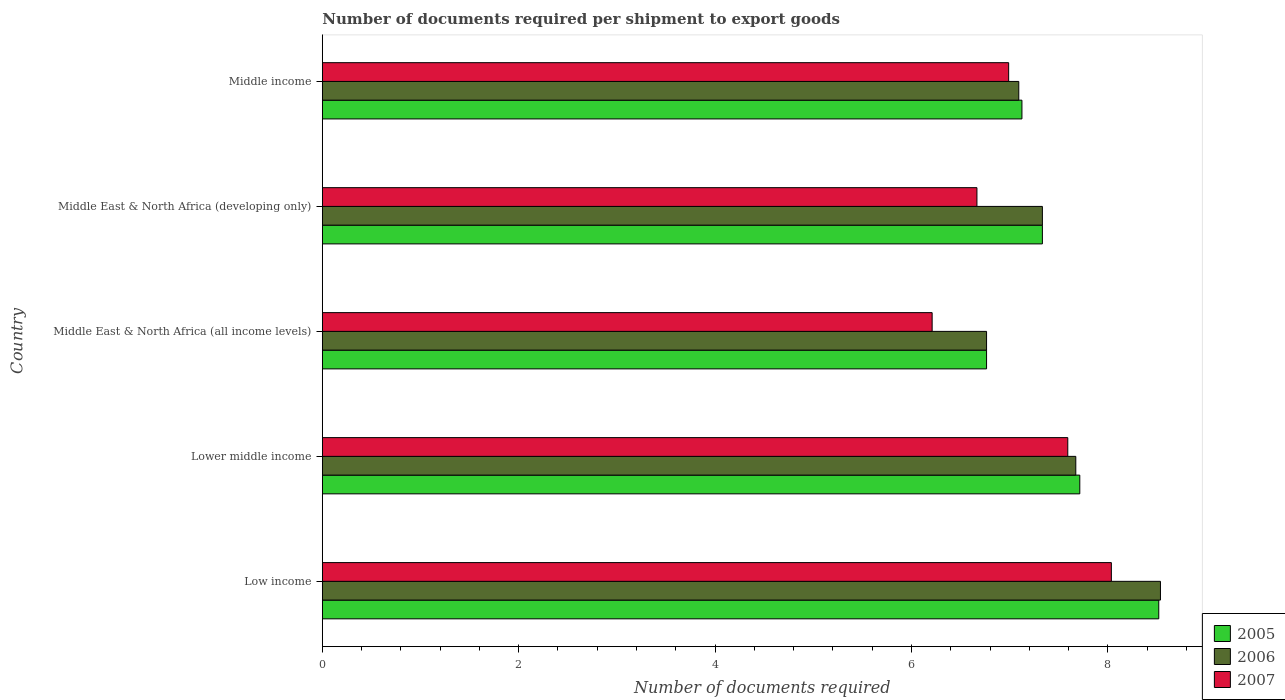Are the number of bars per tick equal to the number of legend labels?
Your answer should be very brief. Yes. Are the number of bars on each tick of the Y-axis equal?
Offer a very short reply. Yes. How many bars are there on the 3rd tick from the bottom?
Provide a succinct answer. 3. What is the label of the 2nd group of bars from the top?
Your answer should be compact. Middle East & North Africa (developing only). What is the number of documents required per shipment to export goods in 2006 in Middle East & North Africa (all income levels)?
Offer a very short reply. 6.76. Across all countries, what is the maximum number of documents required per shipment to export goods in 2006?
Keep it short and to the point. 8.54. Across all countries, what is the minimum number of documents required per shipment to export goods in 2005?
Your answer should be very brief. 6.76. In which country was the number of documents required per shipment to export goods in 2005 minimum?
Provide a short and direct response. Middle East & North Africa (all income levels). What is the total number of documents required per shipment to export goods in 2005 in the graph?
Offer a terse response. 37.46. What is the difference between the number of documents required per shipment to export goods in 2006 in Middle East & North Africa (all income levels) and that in Middle East & North Africa (developing only)?
Make the answer very short. -0.57. What is the difference between the number of documents required per shipment to export goods in 2006 in Middle East & North Africa (developing only) and the number of documents required per shipment to export goods in 2005 in Middle East & North Africa (all income levels)?
Offer a terse response. 0.57. What is the average number of documents required per shipment to export goods in 2005 per country?
Offer a terse response. 7.49. What is the difference between the number of documents required per shipment to export goods in 2006 and number of documents required per shipment to export goods in 2007 in Middle income?
Your response must be concise. 0.1. In how many countries, is the number of documents required per shipment to export goods in 2007 greater than 4 ?
Keep it short and to the point. 5. What is the ratio of the number of documents required per shipment to export goods in 2005 in Middle East & North Africa (all income levels) to that in Middle income?
Ensure brevity in your answer.  0.95. Is the number of documents required per shipment to export goods in 2007 in Middle East & North Africa (all income levels) less than that in Middle income?
Your answer should be compact. Yes. Is the difference between the number of documents required per shipment to export goods in 2006 in Lower middle income and Middle East & North Africa (developing only) greater than the difference between the number of documents required per shipment to export goods in 2007 in Lower middle income and Middle East & North Africa (developing only)?
Provide a short and direct response. No. What is the difference between the highest and the second highest number of documents required per shipment to export goods in 2005?
Provide a succinct answer. 0.8. What is the difference between the highest and the lowest number of documents required per shipment to export goods in 2006?
Provide a succinct answer. 1.77. What does the 2nd bar from the top in Middle East & North Africa (all income levels) represents?
Your answer should be compact. 2006. What does the 3rd bar from the bottom in Low income represents?
Offer a very short reply. 2007. Is it the case that in every country, the sum of the number of documents required per shipment to export goods in 2005 and number of documents required per shipment to export goods in 2007 is greater than the number of documents required per shipment to export goods in 2006?
Provide a succinct answer. Yes. Are all the bars in the graph horizontal?
Your response must be concise. Yes. Where does the legend appear in the graph?
Keep it short and to the point. Bottom right. How many legend labels are there?
Your response must be concise. 3. How are the legend labels stacked?
Ensure brevity in your answer.  Vertical. What is the title of the graph?
Make the answer very short. Number of documents required per shipment to export goods. Does "1994" appear as one of the legend labels in the graph?
Give a very brief answer. No. What is the label or title of the X-axis?
Keep it short and to the point. Number of documents required. What is the label or title of the Y-axis?
Provide a succinct answer. Country. What is the Number of documents required in 2005 in Low income?
Give a very brief answer. 8.52. What is the Number of documents required in 2006 in Low income?
Provide a succinct answer. 8.54. What is the Number of documents required of 2007 in Low income?
Ensure brevity in your answer.  8.04. What is the Number of documents required of 2005 in Lower middle income?
Provide a succinct answer. 7.71. What is the Number of documents required in 2006 in Lower middle income?
Provide a short and direct response. 7.67. What is the Number of documents required of 2007 in Lower middle income?
Provide a succinct answer. 7.59. What is the Number of documents required in 2005 in Middle East & North Africa (all income levels)?
Ensure brevity in your answer.  6.76. What is the Number of documents required of 2006 in Middle East & North Africa (all income levels)?
Offer a very short reply. 6.76. What is the Number of documents required in 2007 in Middle East & North Africa (all income levels)?
Make the answer very short. 6.21. What is the Number of documents required in 2005 in Middle East & North Africa (developing only)?
Make the answer very short. 7.33. What is the Number of documents required in 2006 in Middle East & North Africa (developing only)?
Your answer should be compact. 7.33. What is the Number of documents required in 2007 in Middle East & North Africa (developing only)?
Keep it short and to the point. 6.67. What is the Number of documents required in 2005 in Middle income?
Provide a short and direct response. 7.12. What is the Number of documents required of 2006 in Middle income?
Your answer should be very brief. 7.09. What is the Number of documents required of 2007 in Middle income?
Make the answer very short. 6.99. Across all countries, what is the maximum Number of documents required in 2005?
Provide a succinct answer. 8.52. Across all countries, what is the maximum Number of documents required in 2006?
Provide a short and direct response. 8.54. Across all countries, what is the maximum Number of documents required of 2007?
Ensure brevity in your answer.  8.04. Across all countries, what is the minimum Number of documents required in 2005?
Your answer should be very brief. 6.76. Across all countries, what is the minimum Number of documents required of 2006?
Make the answer very short. 6.76. Across all countries, what is the minimum Number of documents required in 2007?
Give a very brief answer. 6.21. What is the total Number of documents required in 2005 in the graph?
Your answer should be compact. 37.46. What is the total Number of documents required of 2006 in the graph?
Offer a terse response. 37.4. What is the total Number of documents required of 2007 in the graph?
Provide a succinct answer. 35.49. What is the difference between the Number of documents required in 2005 in Low income and that in Lower middle income?
Offer a very short reply. 0.8. What is the difference between the Number of documents required of 2006 in Low income and that in Lower middle income?
Provide a short and direct response. 0.86. What is the difference between the Number of documents required of 2007 in Low income and that in Lower middle income?
Make the answer very short. 0.44. What is the difference between the Number of documents required in 2005 in Low income and that in Middle East & North Africa (all income levels)?
Keep it short and to the point. 1.75. What is the difference between the Number of documents required of 2006 in Low income and that in Middle East & North Africa (all income levels)?
Keep it short and to the point. 1.77. What is the difference between the Number of documents required in 2007 in Low income and that in Middle East & North Africa (all income levels)?
Offer a very short reply. 1.83. What is the difference between the Number of documents required of 2005 in Low income and that in Middle East & North Africa (developing only)?
Give a very brief answer. 1.19. What is the difference between the Number of documents required in 2006 in Low income and that in Middle East & North Africa (developing only)?
Provide a succinct answer. 1.2. What is the difference between the Number of documents required in 2007 in Low income and that in Middle East & North Africa (developing only)?
Your answer should be compact. 1.37. What is the difference between the Number of documents required of 2005 in Low income and that in Middle income?
Ensure brevity in your answer.  1.39. What is the difference between the Number of documents required of 2006 in Low income and that in Middle income?
Make the answer very short. 1.44. What is the difference between the Number of documents required of 2007 in Low income and that in Middle income?
Keep it short and to the point. 1.05. What is the difference between the Number of documents required in 2005 in Lower middle income and that in Middle East & North Africa (all income levels)?
Keep it short and to the point. 0.95. What is the difference between the Number of documents required in 2006 in Lower middle income and that in Middle East & North Africa (all income levels)?
Offer a very short reply. 0.91. What is the difference between the Number of documents required of 2007 in Lower middle income and that in Middle East & North Africa (all income levels)?
Offer a very short reply. 1.38. What is the difference between the Number of documents required of 2005 in Lower middle income and that in Middle East & North Africa (developing only)?
Your answer should be compact. 0.38. What is the difference between the Number of documents required of 2006 in Lower middle income and that in Middle East & North Africa (developing only)?
Give a very brief answer. 0.34. What is the difference between the Number of documents required of 2007 in Lower middle income and that in Middle East & North Africa (developing only)?
Keep it short and to the point. 0.93. What is the difference between the Number of documents required in 2005 in Lower middle income and that in Middle income?
Provide a short and direct response. 0.59. What is the difference between the Number of documents required in 2006 in Lower middle income and that in Middle income?
Offer a very short reply. 0.58. What is the difference between the Number of documents required of 2007 in Lower middle income and that in Middle income?
Provide a short and direct response. 0.6. What is the difference between the Number of documents required of 2005 in Middle East & North Africa (all income levels) and that in Middle East & North Africa (developing only)?
Offer a terse response. -0.57. What is the difference between the Number of documents required in 2006 in Middle East & North Africa (all income levels) and that in Middle East & North Africa (developing only)?
Give a very brief answer. -0.57. What is the difference between the Number of documents required of 2007 in Middle East & North Africa (all income levels) and that in Middle East & North Africa (developing only)?
Offer a terse response. -0.46. What is the difference between the Number of documents required of 2005 in Middle East & North Africa (all income levels) and that in Middle income?
Provide a succinct answer. -0.36. What is the difference between the Number of documents required in 2006 in Middle East & North Africa (all income levels) and that in Middle income?
Provide a succinct answer. -0.33. What is the difference between the Number of documents required in 2007 in Middle East & North Africa (all income levels) and that in Middle income?
Ensure brevity in your answer.  -0.78. What is the difference between the Number of documents required of 2005 in Middle East & North Africa (developing only) and that in Middle income?
Your answer should be compact. 0.21. What is the difference between the Number of documents required in 2006 in Middle East & North Africa (developing only) and that in Middle income?
Offer a terse response. 0.24. What is the difference between the Number of documents required in 2007 in Middle East & North Africa (developing only) and that in Middle income?
Offer a terse response. -0.32. What is the difference between the Number of documents required in 2005 in Low income and the Number of documents required in 2006 in Lower middle income?
Ensure brevity in your answer.  0.84. What is the difference between the Number of documents required in 2005 in Low income and the Number of documents required in 2007 in Lower middle income?
Your response must be concise. 0.93. What is the difference between the Number of documents required of 2006 in Low income and the Number of documents required of 2007 in Lower middle income?
Give a very brief answer. 0.94. What is the difference between the Number of documents required in 2005 in Low income and the Number of documents required in 2006 in Middle East & North Africa (all income levels)?
Offer a very short reply. 1.75. What is the difference between the Number of documents required of 2005 in Low income and the Number of documents required of 2007 in Middle East & North Africa (all income levels)?
Your answer should be compact. 2.31. What is the difference between the Number of documents required in 2006 in Low income and the Number of documents required in 2007 in Middle East & North Africa (all income levels)?
Make the answer very short. 2.33. What is the difference between the Number of documents required of 2005 in Low income and the Number of documents required of 2006 in Middle East & North Africa (developing only)?
Provide a succinct answer. 1.19. What is the difference between the Number of documents required in 2005 in Low income and the Number of documents required in 2007 in Middle East & North Africa (developing only)?
Offer a very short reply. 1.85. What is the difference between the Number of documents required of 2006 in Low income and the Number of documents required of 2007 in Middle East & North Africa (developing only)?
Your answer should be compact. 1.87. What is the difference between the Number of documents required of 2005 in Low income and the Number of documents required of 2006 in Middle income?
Provide a succinct answer. 1.43. What is the difference between the Number of documents required of 2005 in Low income and the Number of documents required of 2007 in Middle income?
Keep it short and to the point. 1.53. What is the difference between the Number of documents required in 2006 in Low income and the Number of documents required in 2007 in Middle income?
Provide a succinct answer. 1.55. What is the difference between the Number of documents required of 2005 in Lower middle income and the Number of documents required of 2006 in Middle East & North Africa (all income levels)?
Offer a terse response. 0.95. What is the difference between the Number of documents required in 2005 in Lower middle income and the Number of documents required in 2007 in Middle East & North Africa (all income levels)?
Your answer should be compact. 1.5. What is the difference between the Number of documents required of 2006 in Lower middle income and the Number of documents required of 2007 in Middle East & North Africa (all income levels)?
Keep it short and to the point. 1.46. What is the difference between the Number of documents required in 2005 in Lower middle income and the Number of documents required in 2006 in Middle East & North Africa (developing only)?
Offer a very short reply. 0.38. What is the difference between the Number of documents required in 2005 in Lower middle income and the Number of documents required in 2007 in Middle East & North Africa (developing only)?
Offer a terse response. 1.05. What is the difference between the Number of documents required in 2006 in Lower middle income and the Number of documents required in 2007 in Middle East & North Africa (developing only)?
Your answer should be compact. 1.01. What is the difference between the Number of documents required of 2005 in Lower middle income and the Number of documents required of 2006 in Middle income?
Ensure brevity in your answer.  0.62. What is the difference between the Number of documents required in 2005 in Lower middle income and the Number of documents required in 2007 in Middle income?
Your answer should be compact. 0.72. What is the difference between the Number of documents required of 2006 in Lower middle income and the Number of documents required of 2007 in Middle income?
Offer a very short reply. 0.68. What is the difference between the Number of documents required in 2005 in Middle East & North Africa (all income levels) and the Number of documents required in 2006 in Middle East & North Africa (developing only)?
Keep it short and to the point. -0.57. What is the difference between the Number of documents required of 2005 in Middle East & North Africa (all income levels) and the Number of documents required of 2007 in Middle East & North Africa (developing only)?
Ensure brevity in your answer.  0.1. What is the difference between the Number of documents required of 2006 in Middle East & North Africa (all income levels) and the Number of documents required of 2007 in Middle East & North Africa (developing only)?
Offer a very short reply. 0.1. What is the difference between the Number of documents required in 2005 in Middle East & North Africa (all income levels) and the Number of documents required in 2006 in Middle income?
Provide a succinct answer. -0.33. What is the difference between the Number of documents required of 2005 in Middle East & North Africa (all income levels) and the Number of documents required of 2007 in Middle income?
Your answer should be compact. -0.23. What is the difference between the Number of documents required in 2006 in Middle East & North Africa (all income levels) and the Number of documents required in 2007 in Middle income?
Your answer should be compact. -0.23. What is the difference between the Number of documents required in 2005 in Middle East & North Africa (developing only) and the Number of documents required in 2006 in Middle income?
Your response must be concise. 0.24. What is the difference between the Number of documents required in 2005 in Middle East & North Africa (developing only) and the Number of documents required in 2007 in Middle income?
Ensure brevity in your answer.  0.34. What is the difference between the Number of documents required of 2006 in Middle East & North Africa (developing only) and the Number of documents required of 2007 in Middle income?
Make the answer very short. 0.34. What is the average Number of documents required in 2005 per country?
Your response must be concise. 7.49. What is the average Number of documents required of 2006 per country?
Offer a terse response. 7.48. What is the average Number of documents required of 2007 per country?
Provide a succinct answer. 7.1. What is the difference between the Number of documents required in 2005 and Number of documents required in 2006 in Low income?
Your answer should be compact. -0.02. What is the difference between the Number of documents required in 2005 and Number of documents required in 2007 in Low income?
Provide a short and direct response. 0.48. What is the difference between the Number of documents required in 2005 and Number of documents required in 2006 in Lower middle income?
Offer a terse response. 0.04. What is the difference between the Number of documents required of 2005 and Number of documents required of 2007 in Lower middle income?
Your response must be concise. 0.12. What is the difference between the Number of documents required in 2006 and Number of documents required in 2007 in Lower middle income?
Give a very brief answer. 0.08. What is the difference between the Number of documents required in 2005 and Number of documents required in 2006 in Middle East & North Africa (all income levels)?
Your answer should be very brief. 0. What is the difference between the Number of documents required of 2005 and Number of documents required of 2007 in Middle East & North Africa (all income levels)?
Keep it short and to the point. 0.55. What is the difference between the Number of documents required of 2006 and Number of documents required of 2007 in Middle East & North Africa (all income levels)?
Ensure brevity in your answer.  0.55. What is the difference between the Number of documents required of 2005 and Number of documents required of 2006 in Middle East & North Africa (developing only)?
Your answer should be very brief. 0. What is the difference between the Number of documents required in 2006 and Number of documents required in 2007 in Middle East & North Africa (developing only)?
Make the answer very short. 0.67. What is the difference between the Number of documents required of 2005 and Number of documents required of 2006 in Middle income?
Give a very brief answer. 0.03. What is the difference between the Number of documents required in 2005 and Number of documents required in 2007 in Middle income?
Your response must be concise. 0.14. What is the difference between the Number of documents required in 2006 and Number of documents required in 2007 in Middle income?
Your answer should be very brief. 0.1. What is the ratio of the Number of documents required in 2005 in Low income to that in Lower middle income?
Provide a short and direct response. 1.1. What is the ratio of the Number of documents required in 2006 in Low income to that in Lower middle income?
Your answer should be compact. 1.11. What is the ratio of the Number of documents required of 2007 in Low income to that in Lower middle income?
Provide a short and direct response. 1.06. What is the ratio of the Number of documents required of 2005 in Low income to that in Middle East & North Africa (all income levels)?
Offer a very short reply. 1.26. What is the ratio of the Number of documents required in 2006 in Low income to that in Middle East & North Africa (all income levels)?
Provide a short and direct response. 1.26. What is the ratio of the Number of documents required in 2007 in Low income to that in Middle East & North Africa (all income levels)?
Provide a short and direct response. 1.29. What is the ratio of the Number of documents required in 2005 in Low income to that in Middle East & North Africa (developing only)?
Offer a terse response. 1.16. What is the ratio of the Number of documents required in 2006 in Low income to that in Middle East & North Africa (developing only)?
Make the answer very short. 1.16. What is the ratio of the Number of documents required of 2007 in Low income to that in Middle East & North Africa (developing only)?
Your answer should be very brief. 1.21. What is the ratio of the Number of documents required of 2005 in Low income to that in Middle income?
Your answer should be very brief. 1.2. What is the ratio of the Number of documents required of 2006 in Low income to that in Middle income?
Keep it short and to the point. 1.2. What is the ratio of the Number of documents required in 2007 in Low income to that in Middle income?
Offer a very short reply. 1.15. What is the ratio of the Number of documents required in 2005 in Lower middle income to that in Middle East & North Africa (all income levels)?
Your response must be concise. 1.14. What is the ratio of the Number of documents required of 2006 in Lower middle income to that in Middle East & North Africa (all income levels)?
Your answer should be compact. 1.13. What is the ratio of the Number of documents required in 2007 in Lower middle income to that in Middle East & North Africa (all income levels)?
Your answer should be very brief. 1.22. What is the ratio of the Number of documents required in 2005 in Lower middle income to that in Middle East & North Africa (developing only)?
Offer a very short reply. 1.05. What is the ratio of the Number of documents required in 2006 in Lower middle income to that in Middle East & North Africa (developing only)?
Keep it short and to the point. 1.05. What is the ratio of the Number of documents required of 2007 in Lower middle income to that in Middle East & North Africa (developing only)?
Offer a very short reply. 1.14. What is the ratio of the Number of documents required of 2005 in Lower middle income to that in Middle income?
Give a very brief answer. 1.08. What is the ratio of the Number of documents required in 2006 in Lower middle income to that in Middle income?
Provide a short and direct response. 1.08. What is the ratio of the Number of documents required in 2007 in Lower middle income to that in Middle income?
Your response must be concise. 1.09. What is the ratio of the Number of documents required of 2005 in Middle East & North Africa (all income levels) to that in Middle East & North Africa (developing only)?
Your answer should be compact. 0.92. What is the ratio of the Number of documents required of 2006 in Middle East & North Africa (all income levels) to that in Middle East & North Africa (developing only)?
Your response must be concise. 0.92. What is the ratio of the Number of documents required of 2007 in Middle East & North Africa (all income levels) to that in Middle East & North Africa (developing only)?
Make the answer very short. 0.93. What is the ratio of the Number of documents required in 2005 in Middle East & North Africa (all income levels) to that in Middle income?
Ensure brevity in your answer.  0.95. What is the ratio of the Number of documents required of 2006 in Middle East & North Africa (all income levels) to that in Middle income?
Ensure brevity in your answer.  0.95. What is the ratio of the Number of documents required of 2007 in Middle East & North Africa (all income levels) to that in Middle income?
Your answer should be very brief. 0.89. What is the ratio of the Number of documents required in 2005 in Middle East & North Africa (developing only) to that in Middle income?
Ensure brevity in your answer.  1.03. What is the ratio of the Number of documents required of 2006 in Middle East & North Africa (developing only) to that in Middle income?
Provide a short and direct response. 1.03. What is the ratio of the Number of documents required in 2007 in Middle East & North Africa (developing only) to that in Middle income?
Keep it short and to the point. 0.95. What is the difference between the highest and the second highest Number of documents required of 2005?
Keep it short and to the point. 0.8. What is the difference between the highest and the second highest Number of documents required in 2006?
Your answer should be compact. 0.86. What is the difference between the highest and the second highest Number of documents required in 2007?
Your answer should be compact. 0.44. What is the difference between the highest and the lowest Number of documents required of 2005?
Keep it short and to the point. 1.75. What is the difference between the highest and the lowest Number of documents required of 2006?
Provide a succinct answer. 1.77. What is the difference between the highest and the lowest Number of documents required of 2007?
Ensure brevity in your answer.  1.83. 